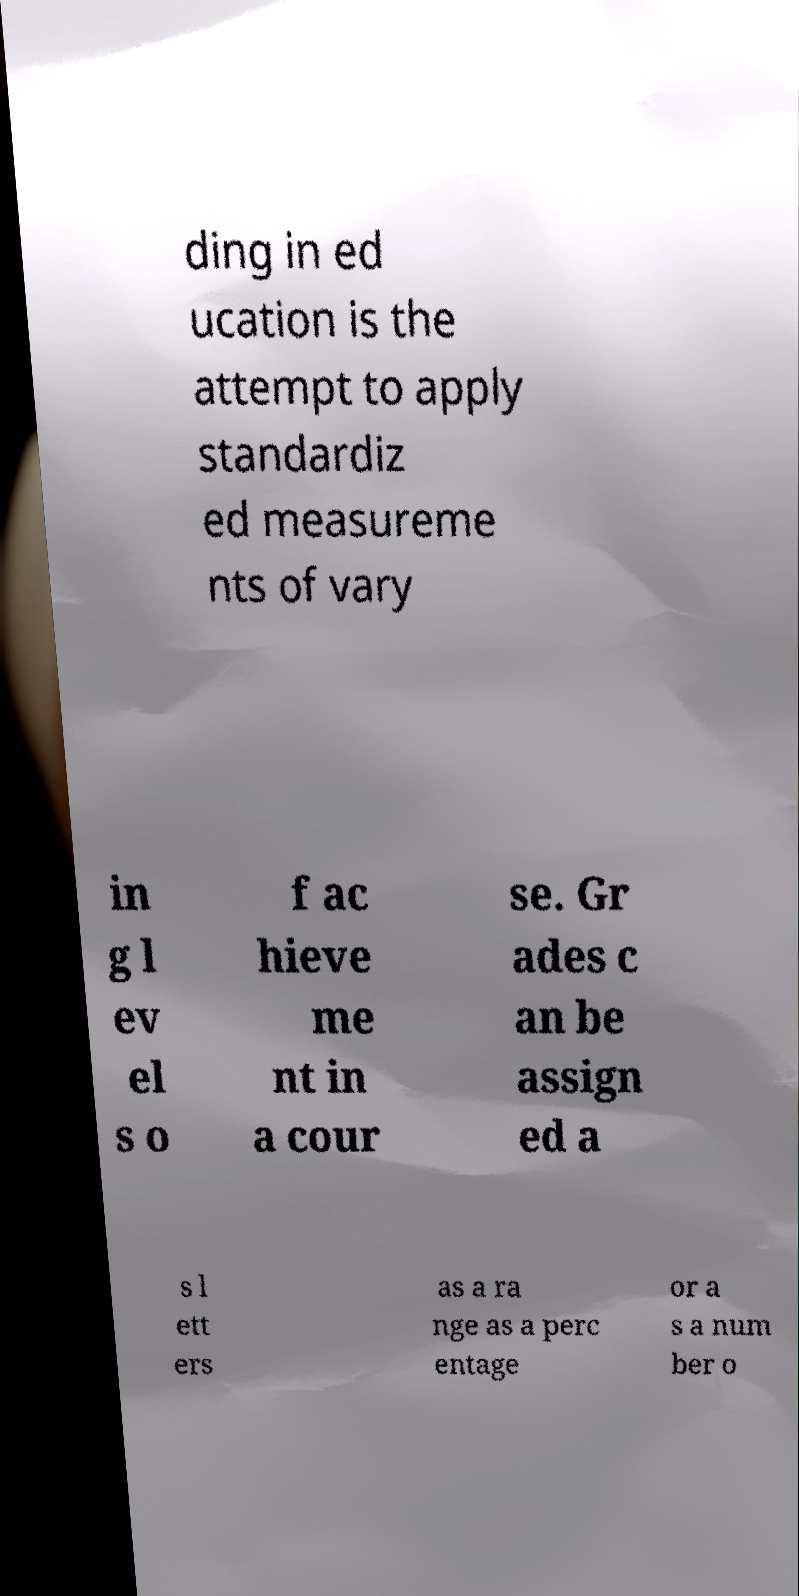Please identify and transcribe the text found in this image. ding in ed ucation is the attempt to apply standardiz ed measureme nts of vary in g l ev el s o f ac hieve me nt in a cour se. Gr ades c an be assign ed a s l ett ers as a ra nge as a perc entage or a s a num ber o 